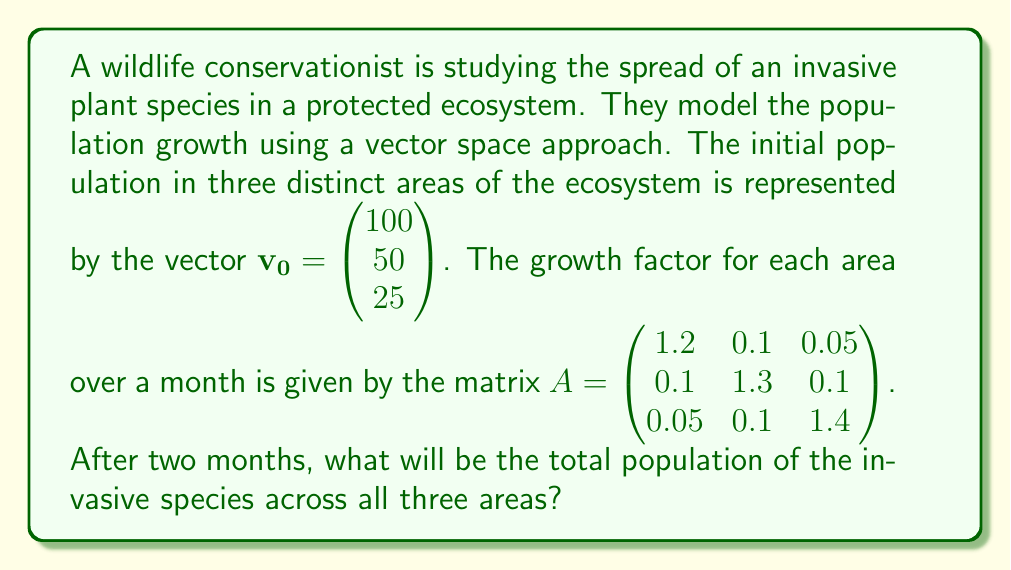Provide a solution to this math problem. To solve this problem, we need to apply the growth matrix twice to the initial population vector and then sum the resulting components. Let's break it down step-by-step:

1) First, let's calculate the population after one month:
   $\mathbf{v_1} = A\mathbf{v_0}$
   
   $$\mathbf{v_1} = \begin{pmatrix} 1.2 & 0.1 & 0.05 \\ 0.1 & 1.3 & 0.1 \\ 0.05 & 0.1 & 1.4 \end{pmatrix} \begin{pmatrix} 100 \\ 50 \\ 25 \end{pmatrix}$$
   
   $$= \begin{pmatrix} (1.2 \times 100) + (0.1 \times 50) + (0.05 \times 25) \\ (0.1 \times 100) + (1.3 \times 50) + (0.1 \times 25) \\ (0.05 \times 100) + (0.1 \times 50) + (1.4 \times 25) \end{pmatrix}$$
   
   $$= \begin{pmatrix} 120 + 5 + 1.25 \\ 10 + 65 + 2.5 \\ 5 + 5 + 35 \end{pmatrix} = \begin{pmatrix} 126.25 \\ 77.5 \\ 45 \end{pmatrix}$$

2) Now, let's calculate the population after two months:
   $\mathbf{v_2} = A\mathbf{v_1}$
   
   $$\mathbf{v_2} = \begin{pmatrix} 1.2 & 0.1 & 0.05 \\ 0.1 & 1.3 & 0.1 \\ 0.05 & 0.1 & 1.4 \end{pmatrix} \begin{pmatrix} 126.25 \\ 77.5 \\ 45 \end{pmatrix}$$
   
   $$= \begin{pmatrix} (1.2 \times 126.25) + (0.1 \times 77.5) + (0.05 \times 45) \\ (0.1 \times 126.25) + (1.3 \times 77.5) + (0.1 \times 45) \\ (0.05 \times 126.25) + (0.1 \times 77.5) + (1.4 \times 45) \end{pmatrix}$$
   
   $$= \begin{pmatrix} 151.5 + 7.75 + 2.25 \\ 12.625 + 100.75 + 4.5 \\ 6.3125 + 7.75 + 63 \end{pmatrix} = \begin{pmatrix} 161.5 \\ 117.875 \\ 77.0625 \end{pmatrix}$$

3) To get the total population, we sum the components of $\mathbf{v_2}$:

   Total population = 161.5 + 117.875 + 77.0625 = 356.4375
Answer: The total population of the invasive species across all three areas after two months will be approximately 356 individuals. 